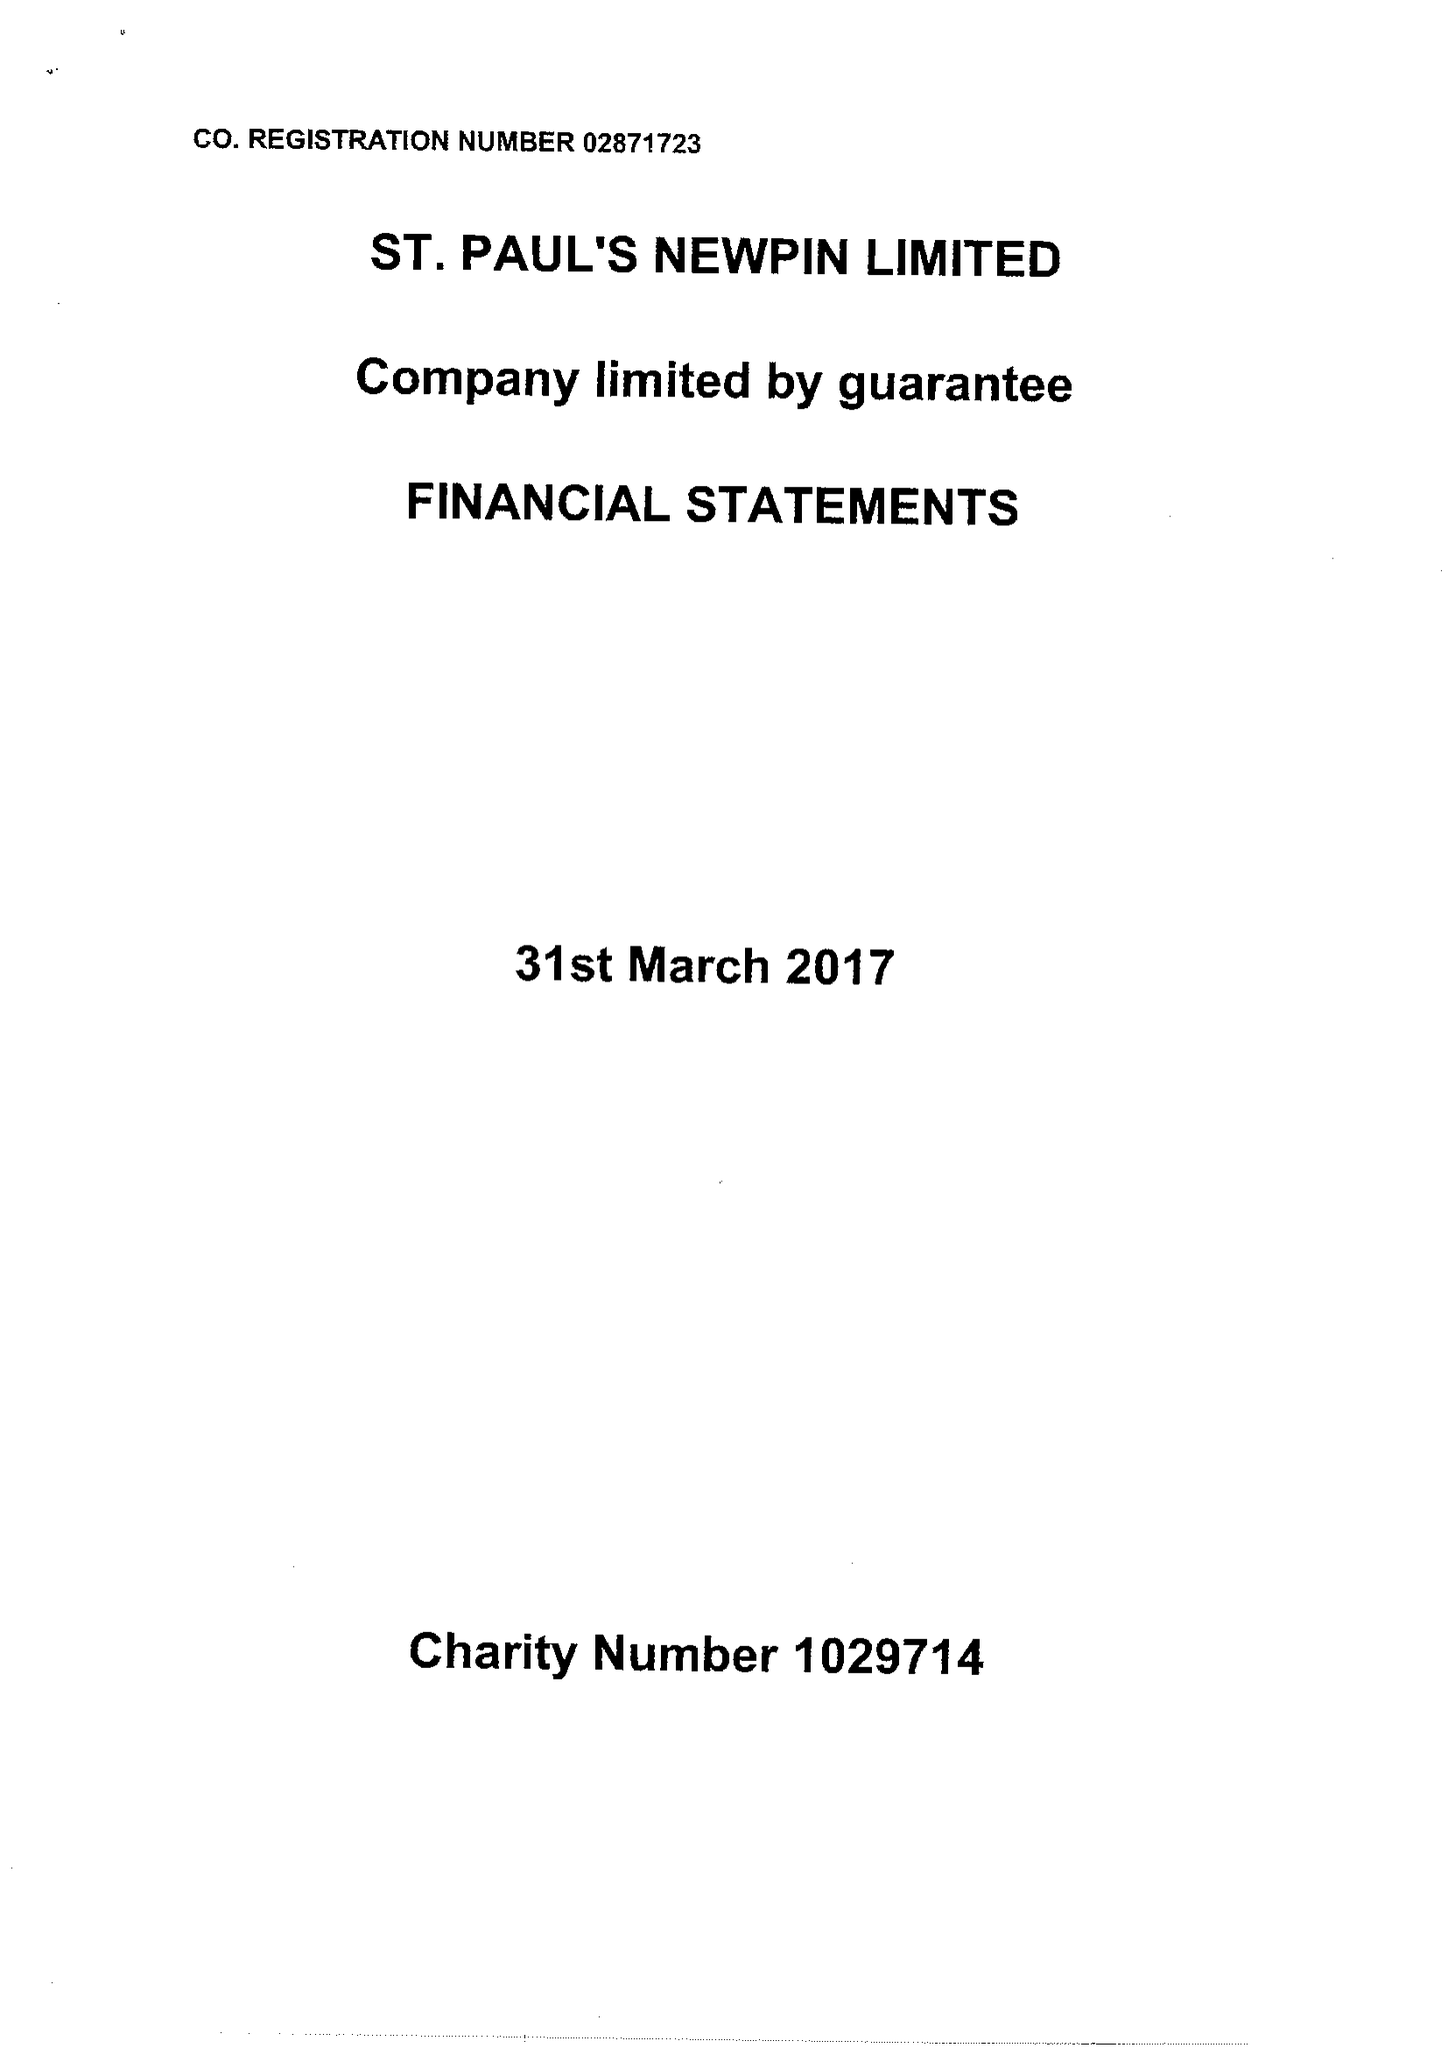What is the value for the charity_name?
Answer the question using a single word or phrase. St Paul's Newpin Ltd. 